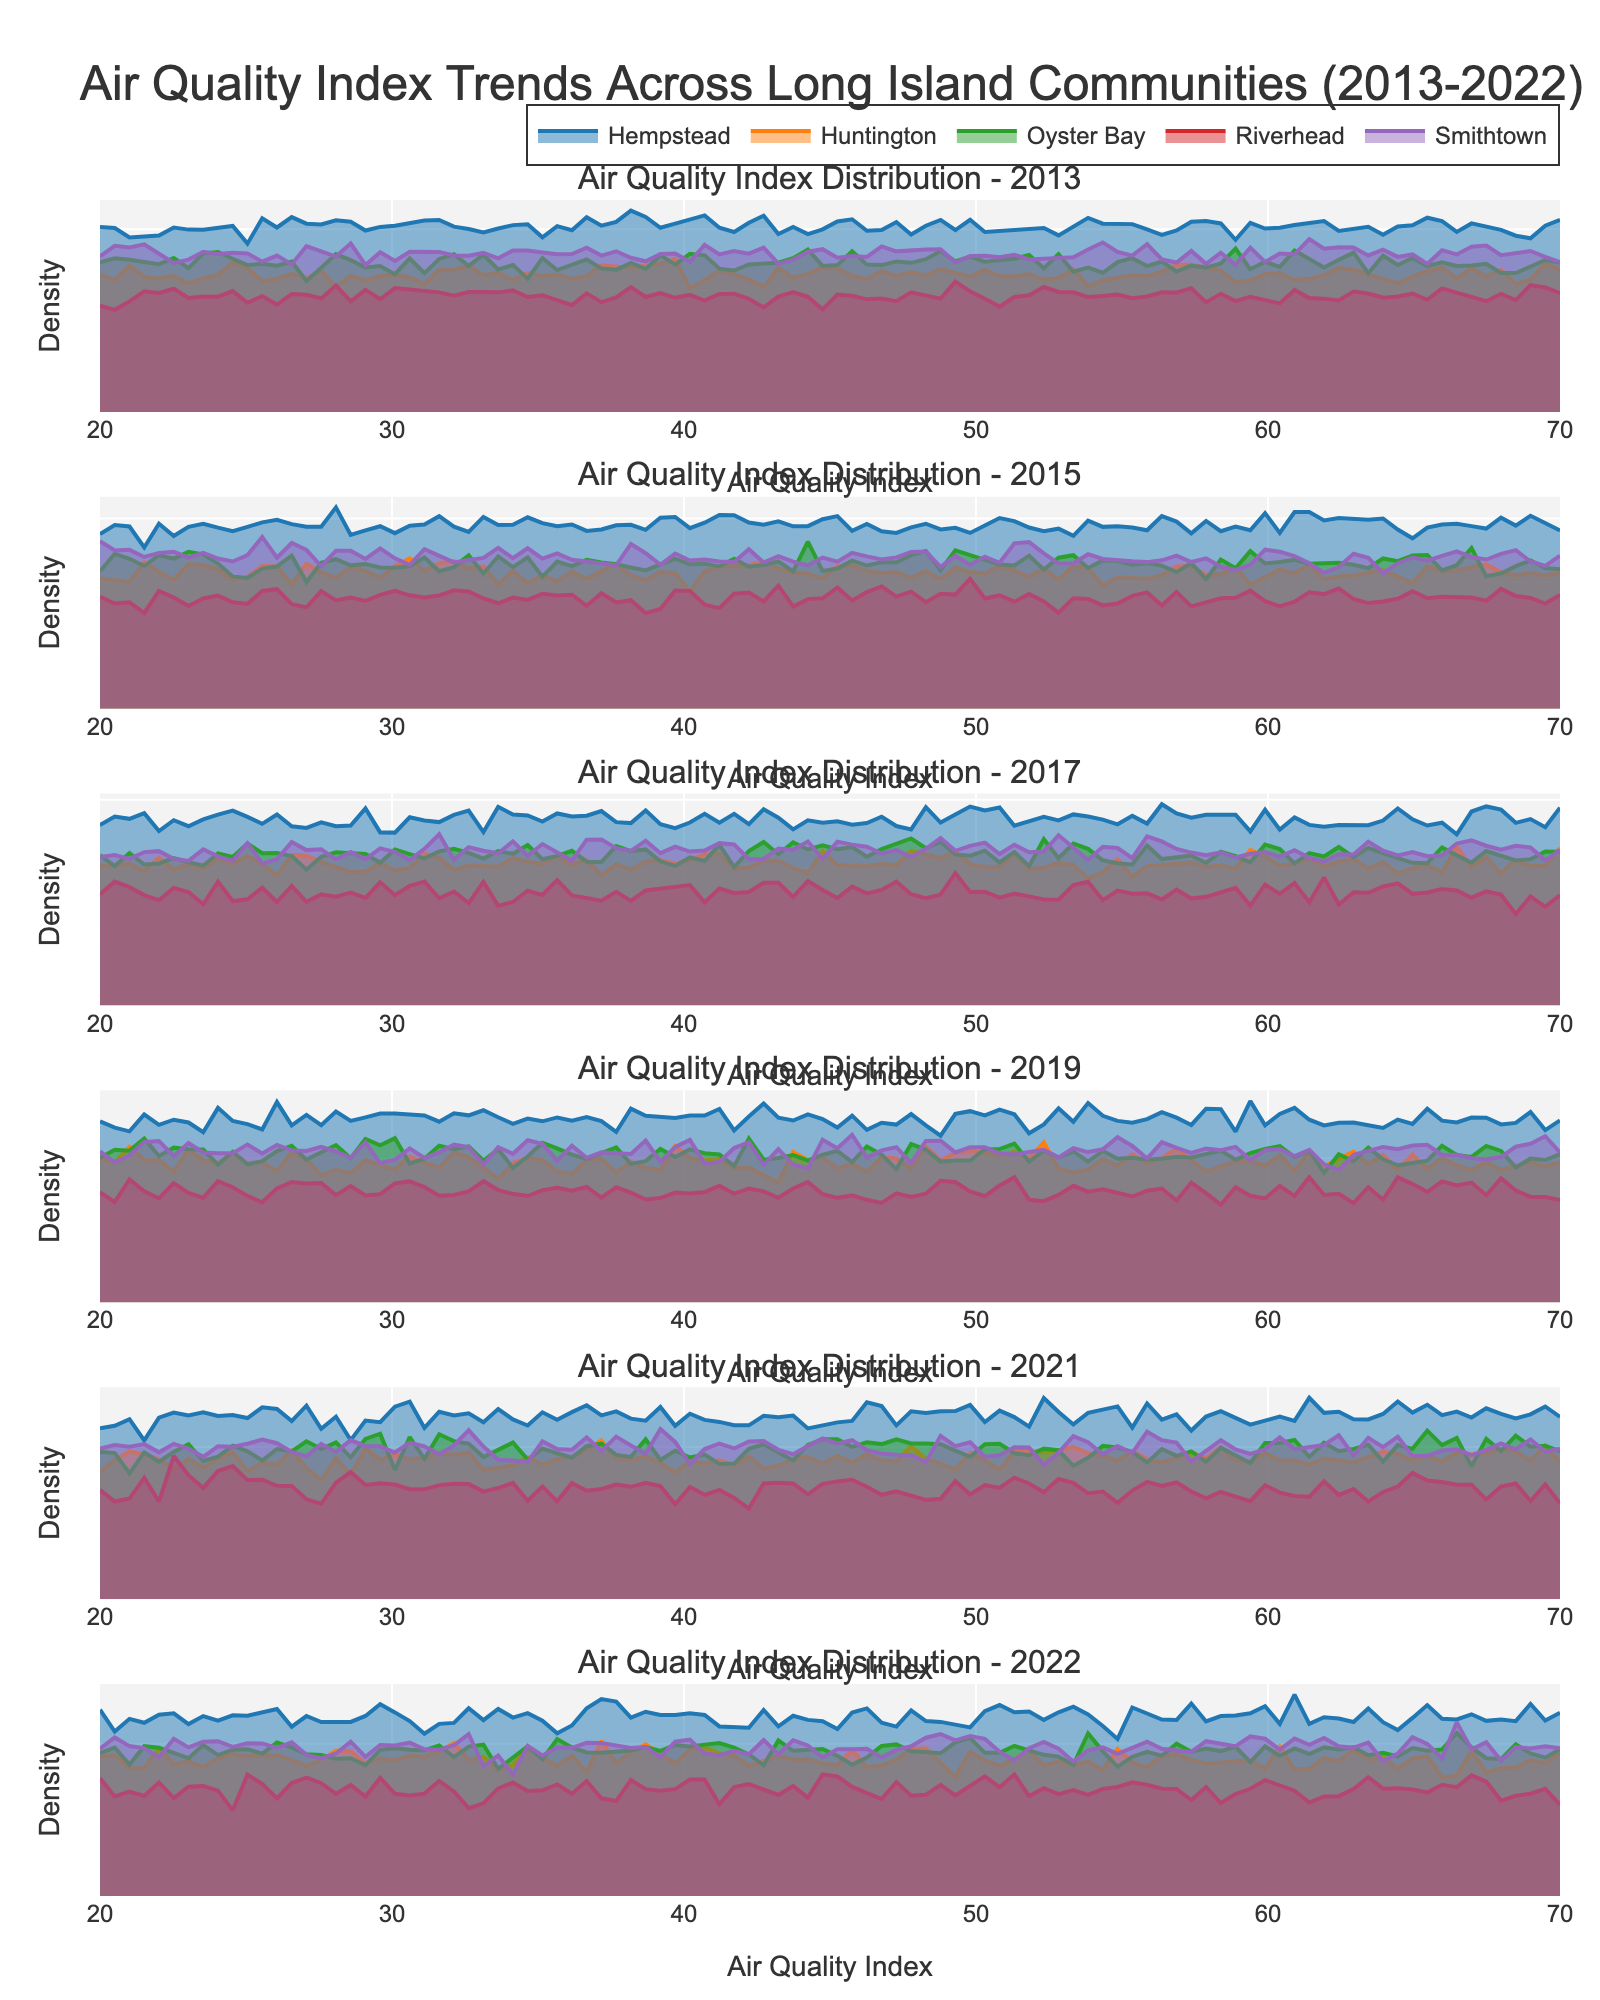1. What is the title of the figure? The title of the figure is displayed at the top of the plot. It is clearly visible and summarizes the content of the figure.
Answer: Air Quality Index Trends Across Long Island Communities (2013-2022) 2. How many subplots are there in the figure? The figure has a subplot for each year provided sequentially. Each subplot title includes the corresponding year. By counting them, we can determine the total number.
Answer: 6 3. Which community has the highest density peak in the year 2022? To determine the highest density peak in 2022, look for the subplot labeled 2022 and observe the density lines. The community with the tallest peak represents the highest density.
Answer: Huntington 4. Compare the AQI values of Riverhead in 2013 and 2022. How have they changed? Locate the density line for Riverhead in the subplots for 2013 and 2022. Note the peaks and compare them to determine the change in AQI value over the years.
Answer: Decreased 5. What is the trend in AQI values for the community of Hempstead from 2013 to 2022? Observe the subplots for each year and follow the density line for Hempstead. Note the change in the location of the peak for each year to identify the trend.
Answer: Decreasing 6. Which community consistently shows the lowest AQI values across the years? Analyze each subplot from 2013 to 2022 to find the community whose density line peaks at the lowest AQI values consistently over the years.
Answer: Riverhead 7. In which year do we see the least variation in AQI values across all communities? Examine the subplots to identify which year has density lines that are most closely clustered together, indicating minimal variation in AQI values.
Answer: 2013 8. Are there any noticeable anomalies or outliers in the AQI data for 2021? Analyze the subplot for 2021 to check if any community has a significantly different density line compared to the others, indicating an anomaly or outlier.
Answer: No significant anomalies 9. How does the AQI density for Smithtown in 2015 compare to that in 2017? Compare the density lines for Smithtown in the subplots for 2015 and 2017, observing any shifts or changes in the peaks to determine how the AQI values have changed.
Answer: Slightly lower in 2017 10. Which year shows the most improvement in air quality for Huntington? Track the density line for Huntington across each subplot to identify the year with the biggest shift towards lower AQI values, indicating an improvement in air quality.
Answer: 2021 